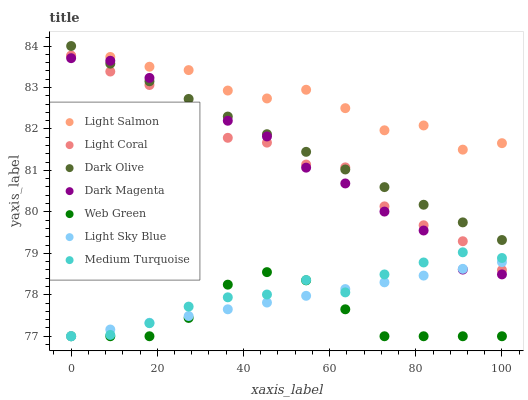Does Web Green have the minimum area under the curve?
Answer yes or no. Yes. Does Light Salmon have the maximum area under the curve?
Answer yes or no. Yes. Does Dark Magenta have the minimum area under the curve?
Answer yes or no. No. Does Dark Magenta have the maximum area under the curve?
Answer yes or no. No. Is Dark Olive the smoothest?
Answer yes or no. Yes. Is Light Salmon the roughest?
Answer yes or no. Yes. Is Dark Magenta the smoothest?
Answer yes or no. No. Is Dark Magenta the roughest?
Answer yes or no. No. Does Web Green have the lowest value?
Answer yes or no. Yes. Does Dark Magenta have the lowest value?
Answer yes or no. No. Does Dark Olive have the highest value?
Answer yes or no. Yes. Does Dark Magenta have the highest value?
Answer yes or no. No. Is Medium Turquoise less than Light Salmon?
Answer yes or no. Yes. Is Dark Magenta greater than Web Green?
Answer yes or no. Yes. Does Medium Turquoise intersect Light Coral?
Answer yes or no. Yes. Is Medium Turquoise less than Light Coral?
Answer yes or no. No. Is Medium Turquoise greater than Light Coral?
Answer yes or no. No. Does Medium Turquoise intersect Light Salmon?
Answer yes or no. No. 